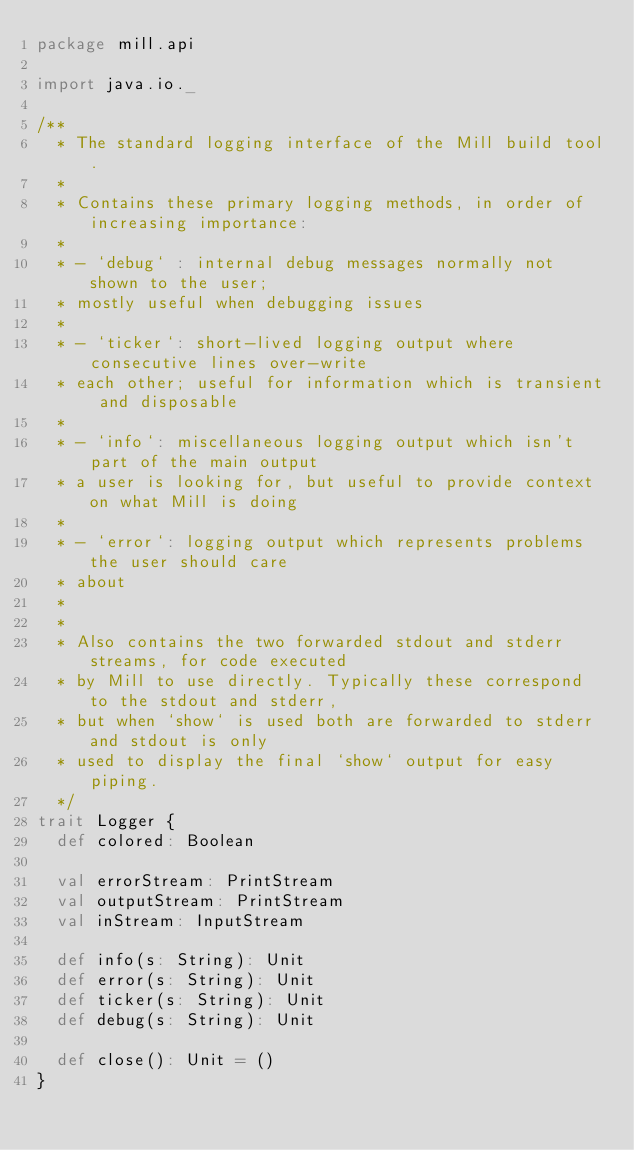<code> <loc_0><loc_0><loc_500><loc_500><_Scala_>package mill.api

import java.io._

/**
  * The standard logging interface of the Mill build tool.
  *
  * Contains these primary logging methods, in order of increasing importance:
  *
  * - `debug` : internal debug messages normally not shown to the user;
  * mostly useful when debugging issues
  *
  * - `ticker`: short-lived logging output where consecutive lines over-write
  * each other; useful for information which is transient and disposable
  *
  * - `info`: miscellaneous logging output which isn't part of the main output
  * a user is looking for, but useful to provide context on what Mill is doing
  *
  * - `error`: logging output which represents problems the user should care
  * about
  *
  *
  * Also contains the two forwarded stdout and stderr streams, for code executed
  * by Mill to use directly. Typically these correspond to the stdout and stderr,
  * but when `show` is used both are forwarded to stderr and stdout is only
  * used to display the final `show` output for easy piping.
  */
trait Logger {
  def colored: Boolean

  val errorStream: PrintStream
  val outputStream: PrintStream
  val inStream: InputStream

  def info(s: String): Unit
  def error(s: String): Unit
  def ticker(s: String): Unit
  def debug(s: String): Unit

  def close(): Unit = ()
}
</code> 